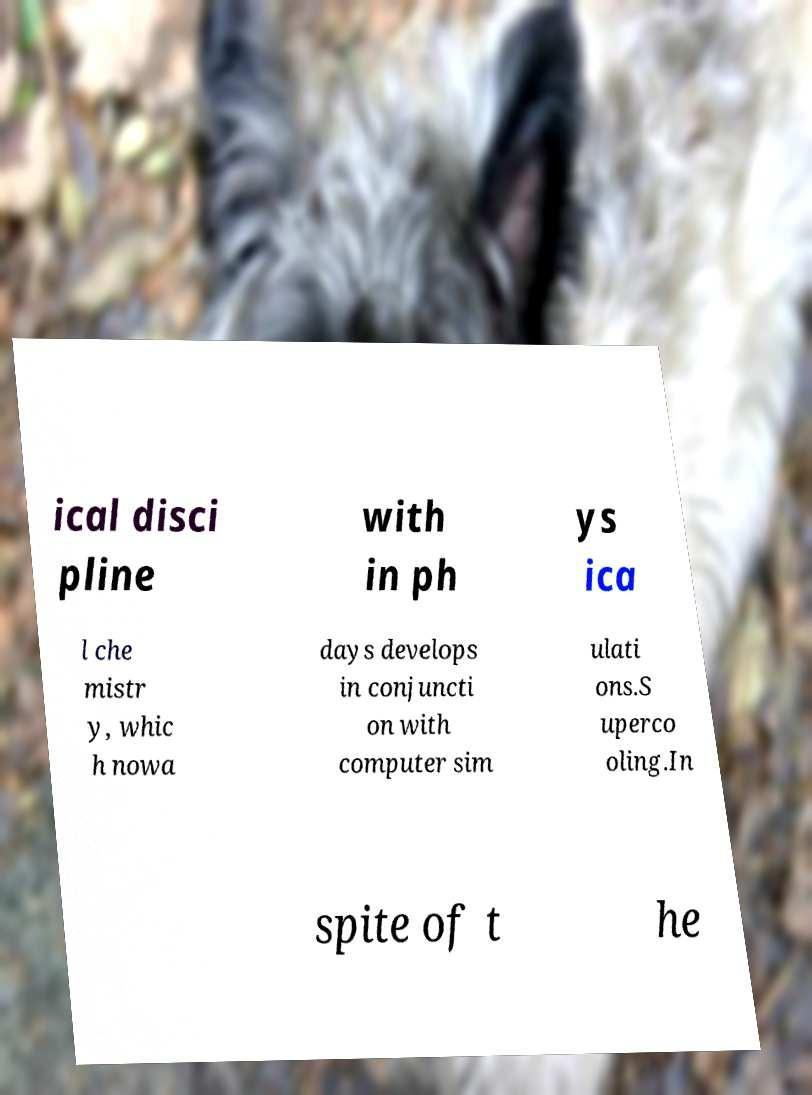Can you read and provide the text displayed in the image?This photo seems to have some interesting text. Can you extract and type it out for me? ical disci pline with in ph ys ica l che mistr y, whic h nowa days develops in conjuncti on with computer sim ulati ons.S uperco oling.In spite of t he 